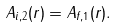Convert formula to latex. <formula><loc_0><loc_0><loc_500><loc_500>A _ { i , 2 } ( r ) = A _ { f , 1 } ( r ) .</formula> 